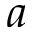<formula> <loc_0><loc_0><loc_500><loc_500>a</formula> 